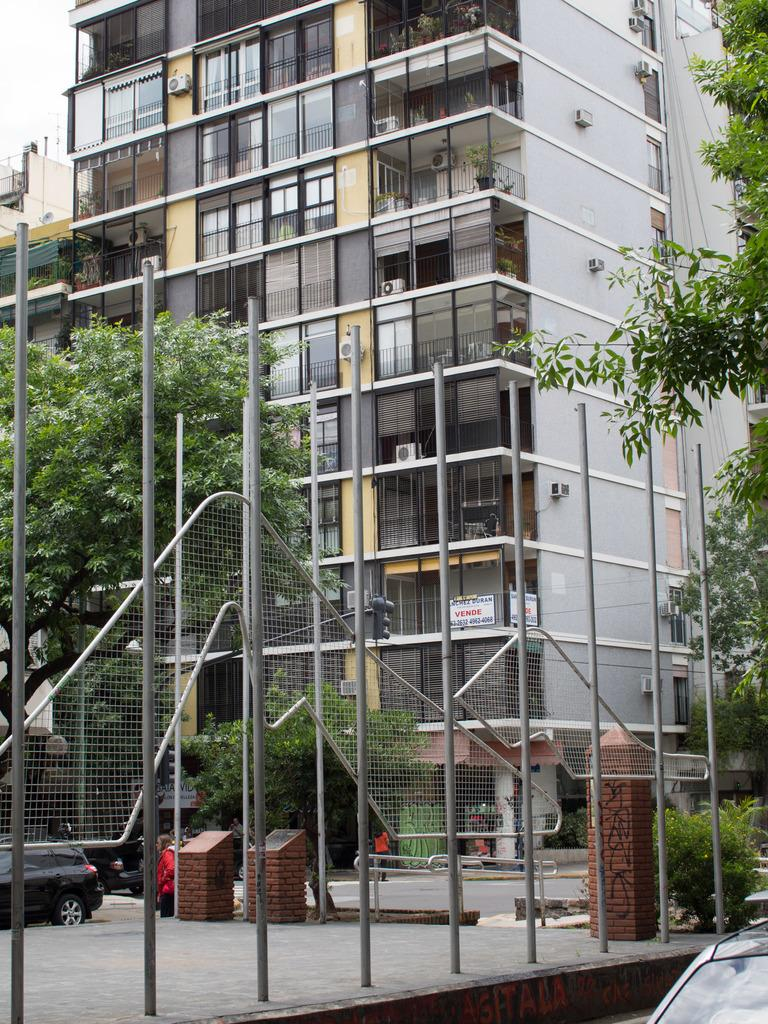What type of vegetation is on the left side of the image? There are trees on the left side of the image. What type of vegetation is on the right side of the image? There are trees on the right side of the image. What can be seen in the background of the image? There is a building in the background of the image. What type of vehicles are in the middle of the image? There are cars in the middle of the image. How many pairs of jeans are hanging on the trees in the image? There are no jeans present in the image; it features trees, a building, and cars. Is there a goat visible in the image? No, there is no goat present in the image. 